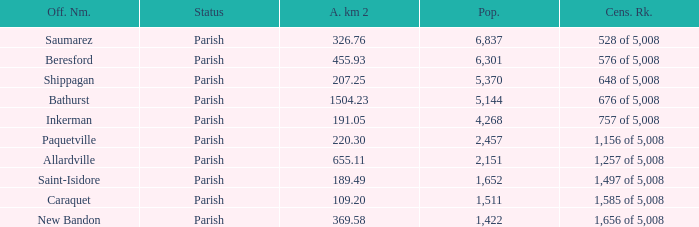What is the Area of the Allardville Parish with a Population smaller than 2,151? None. 